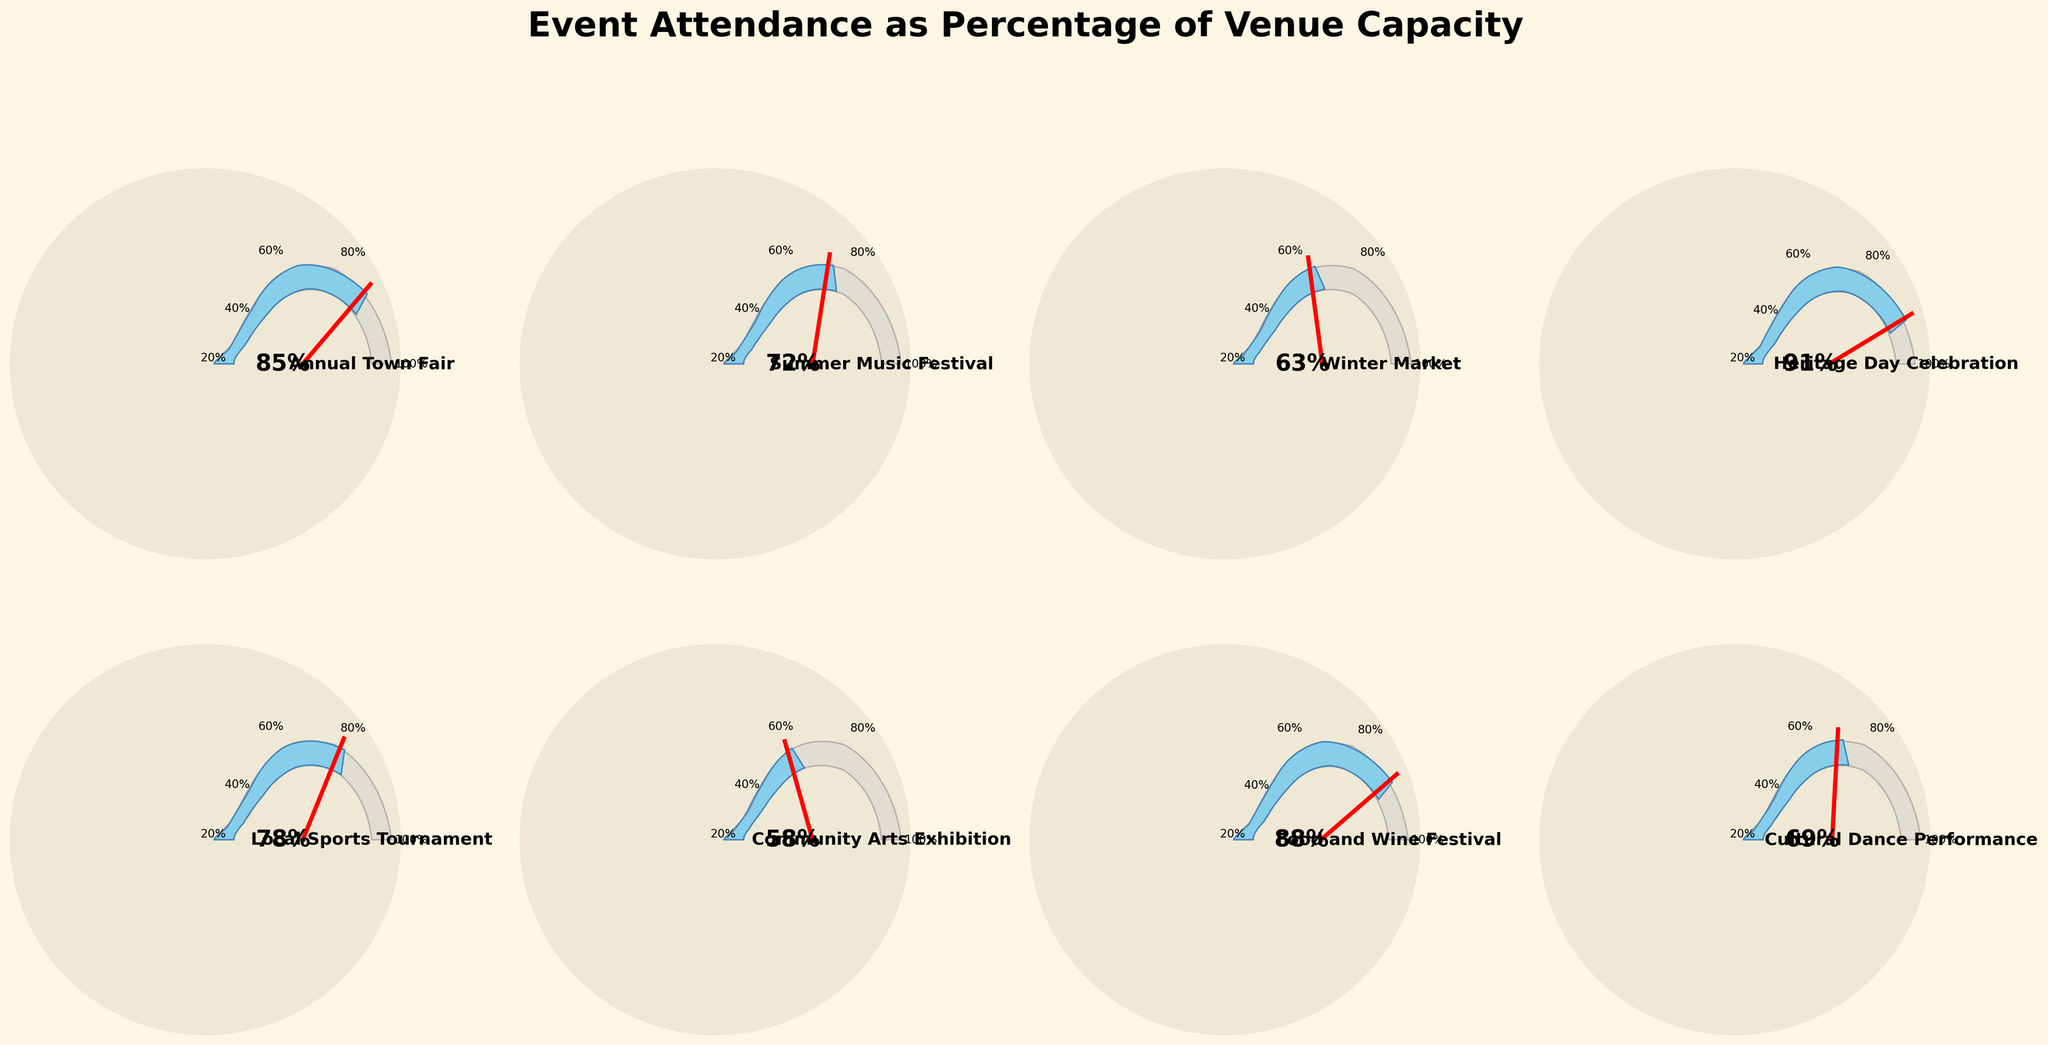what is the title of the figure? The title is positioned at the top center of the figure. By reading it, you can see it says, "Event Attendance as Percentage of Venue Capacity."
Answer: Event Attendance as Percentage of Venue Capacity How many events are represented in the figure? There are gauge charts organized in a 2x4 grid in the figure, each representing a different event. Count them.
Answer: 8 Which event has the highest attendance percentage? To find the highest attendance percentage, look for the gauge that has the needle closest to the maximum value on the scale. The "Heritage Day Celebration" gauge shows 91%, which is the highest.
Answer: Heritage Day Celebration Which event has the lowest attendance percentage? Similar to finding the highest, identify the gauge where the needle is closest to the minimum value on the scale. The "Community Arts Exhibition" gauge shows 58%, which is the lowest.
Answer: Community Arts Exhibition What is the percentage difference between the Annual Town Fair and the Winter Market? Find the percentages for both events. "Annual Town Fair" is at 85%, and "Winter Market" is at 63%. Calculate the difference: 85% - 63% = 22%.
Answer: 22% What is the average attendance percentage of all events combined? Add all the attendance percentages and divide by the number of events (8). The percentages are 85, 72, 63, 91, 78, 58, 88, 69. Sum: 85 + 72 + 63 + 91 + 78 + 58 + 88 + 69 = 604. Average: 604 / 8 = 75.5%.
Answer: 75.5% Which events have attendance percentages greater than 80%? Check each gauge chart for events where the percentage is above 80%. The events meeting this criterion are "Annual Town Fair" (85%), "Heritage Day Celebration" (91%), and "Food and Wine Festival" (88%).
Answer: Annual Town Fair, Heritage Day Celebration, Food and Wine Festival What is the median attendance percentage of the events? List all percentages in numerical order: 58, 63, 69, 72, 78, 85, 88, 91. Since there are 8 data points, the median is the average of the 4th and 5th points. (72 + 78) / 2 = 75%.
Answer: 75% By how much does the attendance percentage of the Cultural Dance Performance fall short of the target of 75%? The percentage for "Cultural Dance Performance" is 69%. Calculate the shortfall from the target of 75%: 75% - 69% = 6%.
Answer: 6% If the Local Sports Tournament increased its attendance percentage by 10%, what would its new percentage be? The current attendance for "Local Sports Tournament" is 78%. Adding 10% gives 78% + 10% = 88%.
Answer: 88% 